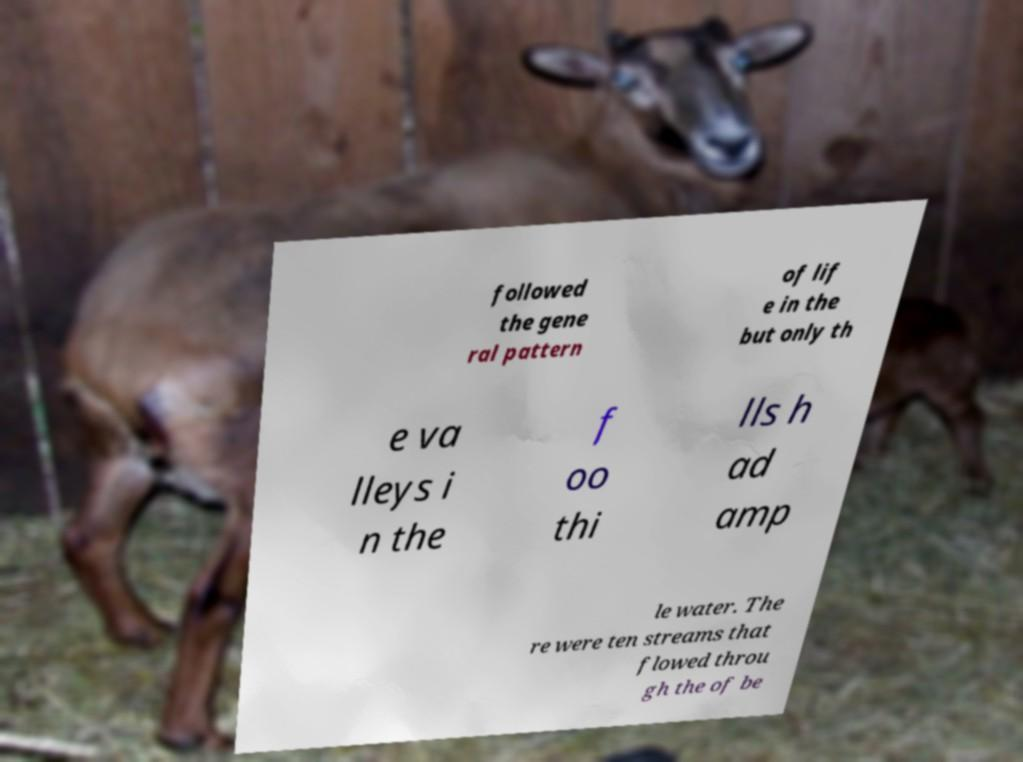For documentation purposes, I need the text within this image transcribed. Could you provide that? followed the gene ral pattern of lif e in the but only th e va lleys i n the f oo thi lls h ad amp le water. The re were ten streams that flowed throu gh the of be 